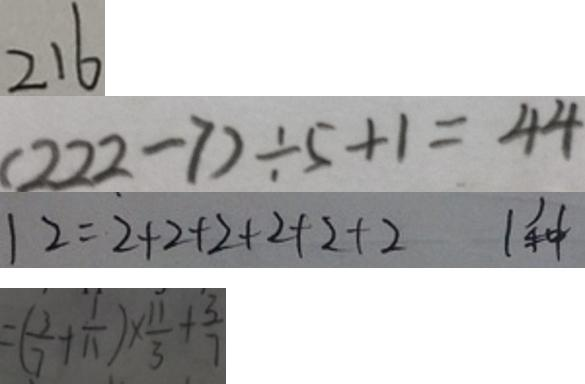Convert formula to latex. <formula><loc_0><loc_0><loc_500><loc_500>2 1 6 
 ( 2 2 2 - 7 ) \div 5 + 1 = 4 4 
 1 2 = 2 + 2 + 2 + 2 + 2 + 2 1 种 
 = ( \frac { 3 } { 7 } + \frac { 1 } { 1 1 } ) \times \frac { 1 1 } { 3 } + \frac { 3 } { 7 }</formula> 